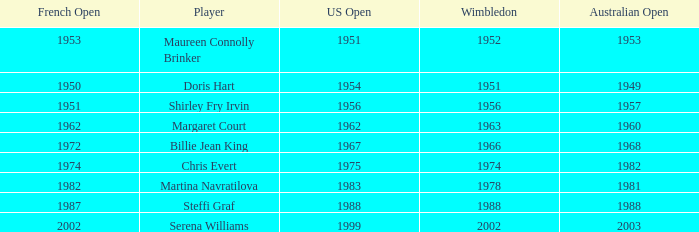What year did Martina Navratilova win Wimbledon? 1978.0. 